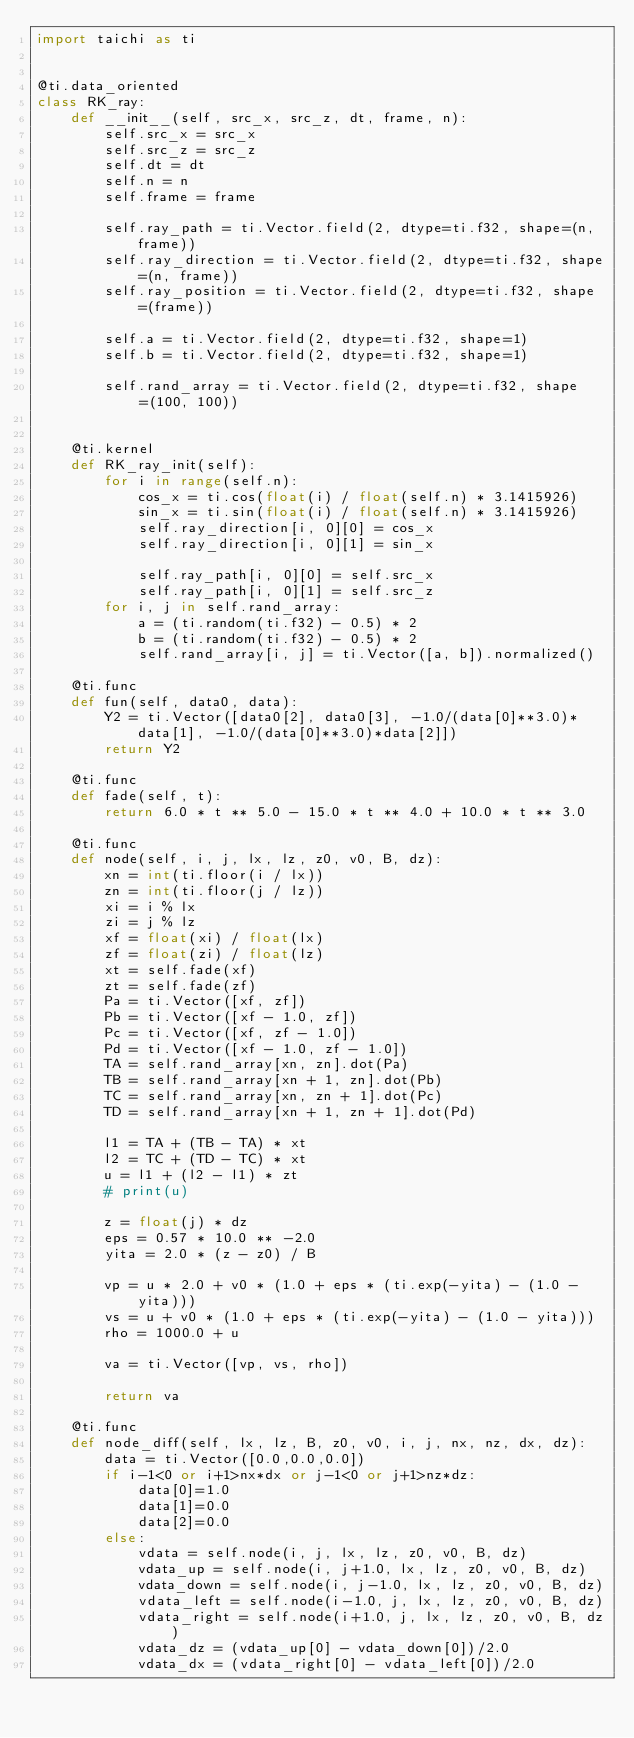<code> <loc_0><loc_0><loc_500><loc_500><_Python_>import taichi as ti


@ti.data_oriented
class RK_ray:
    def __init__(self, src_x, src_z, dt, frame, n):
        self.src_x = src_x
        self.src_z = src_z
        self.dt = dt
        self.n = n
        self.frame = frame

        self.ray_path = ti.Vector.field(2, dtype=ti.f32, shape=(n, frame))
        self.ray_direction = ti.Vector.field(2, dtype=ti.f32, shape=(n, frame))
        self.ray_position = ti.Vector.field(2, dtype=ti.f32, shape=(frame))

        self.a = ti.Vector.field(2, dtype=ti.f32, shape=1)
        self.b = ti.Vector.field(2, dtype=ti.f32, shape=1)

        self.rand_array = ti.Vector.field(2, dtype=ti.f32, shape=(100, 100))


    @ti.kernel
    def RK_ray_init(self):
        for i in range(self.n):
            cos_x = ti.cos(float(i) / float(self.n) * 3.1415926)
            sin_x = ti.sin(float(i) / float(self.n) * 3.1415926)
            self.ray_direction[i, 0][0] = cos_x
            self.ray_direction[i, 0][1] = sin_x

            self.ray_path[i, 0][0] = self.src_x
            self.ray_path[i, 0][1] = self.src_z
        for i, j in self.rand_array:
            a = (ti.random(ti.f32) - 0.5) * 2
            b = (ti.random(ti.f32) - 0.5) * 2
            self.rand_array[i, j] = ti.Vector([a, b]).normalized()

    @ti.func
    def fun(self, data0, data):
        Y2 = ti.Vector([data0[2], data0[3], -1.0/(data[0]**3.0)*data[1], -1.0/(data[0]**3.0)*data[2]]) 
        return Y2

    @ti.func
    def fade(self, t):
        return 6.0 * t ** 5.0 - 15.0 * t ** 4.0 + 10.0 * t ** 3.0

    @ti.func
    def node(self, i, j, lx, lz, z0, v0, B, dz):
        xn = int(ti.floor(i / lx))
        zn = int(ti.floor(j / lz))
        xi = i % lx
        zi = j % lz
        xf = float(xi) / float(lx)
        zf = float(zi) / float(lz)
        xt = self.fade(xf)
        zt = self.fade(zf)
        Pa = ti.Vector([xf, zf])
        Pb = ti.Vector([xf - 1.0, zf])
        Pc = ti.Vector([xf, zf - 1.0])
        Pd = ti.Vector([xf - 1.0, zf - 1.0])
        TA = self.rand_array[xn, zn].dot(Pa)
        TB = self.rand_array[xn + 1, zn].dot(Pb)
        TC = self.rand_array[xn, zn + 1].dot(Pc)
        TD = self.rand_array[xn + 1, zn + 1].dot(Pd)

        l1 = TA + (TB - TA) * xt
        l2 = TC + (TD - TC) * xt
        u = l1 + (l2 - l1) * zt
        # print(u)

        z = float(j) * dz
        eps = 0.57 * 10.0 ** -2.0
        yita = 2.0 * (z - z0) / B

        vp = u * 2.0 + v0 * (1.0 + eps * (ti.exp(-yita) - (1.0 - yita)))
        vs = u + v0 * (1.0 + eps * (ti.exp(-yita) - (1.0 - yita)))
        rho = 1000.0 + u

        va = ti.Vector([vp, vs, rho])

        return va

    @ti.func
    def node_diff(self, lx, lz, B, z0, v0, i, j, nx, nz, dx, dz):
        data = ti.Vector([0.0,0.0,0.0])
        if i-1<0 or i+1>nx*dx or j-1<0 or j+1>nz*dz:
            data[0]=1.0
            data[1]=0.0
            data[2]=0.0
        else:
            vdata = self.node(i, j, lx, lz, z0, v0, B, dz)
            vdata_up = self.node(i, j+1.0, lx, lz, z0, v0, B, dz)
            vdata_down = self.node(i, j-1.0, lx, lz, z0, v0, B, dz)
            vdata_left = self.node(i-1.0, j, lx, lz, z0, v0, B, dz)
            vdata_right = self.node(i+1.0, j, lx, lz, z0, v0, B, dz)
            vdata_dz = (vdata_up[0] - vdata_down[0])/2.0
            vdata_dx = (vdata_right[0] - vdata_left[0])/2.0 </code> 